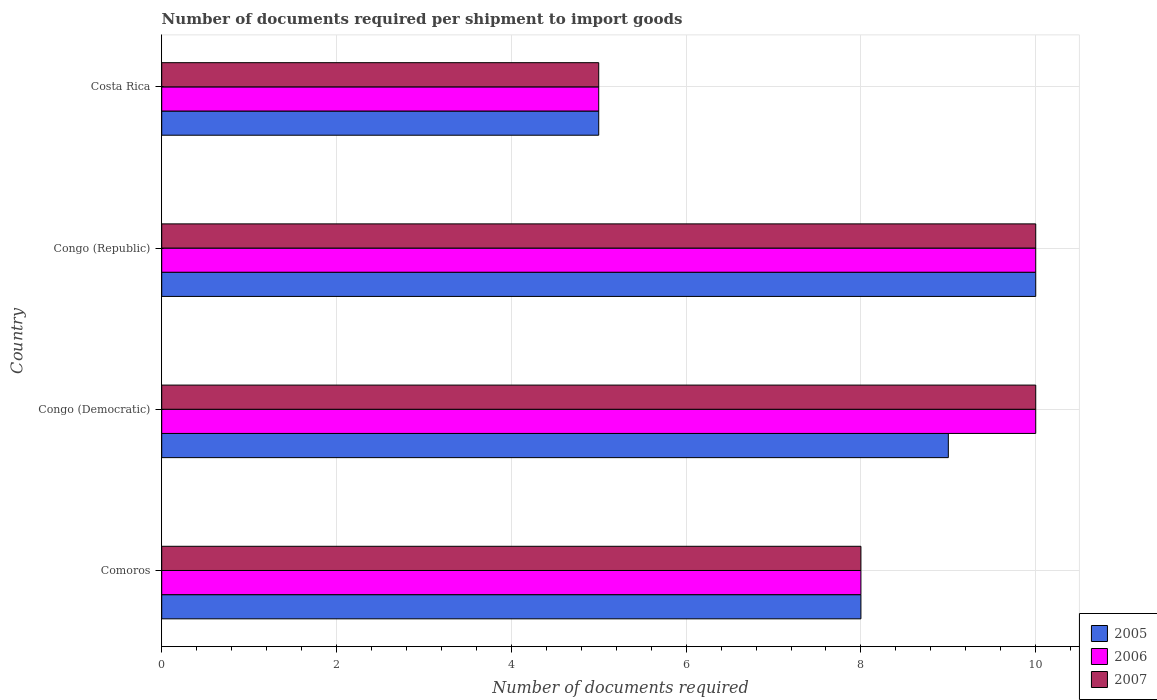Are the number of bars on each tick of the Y-axis equal?
Give a very brief answer. Yes. How many bars are there on the 3rd tick from the bottom?
Provide a short and direct response. 3. What is the label of the 3rd group of bars from the top?
Give a very brief answer. Congo (Democratic). In how many cases, is the number of bars for a given country not equal to the number of legend labels?
Provide a short and direct response. 0. What is the number of documents required per shipment to import goods in 2005 in Comoros?
Offer a very short reply. 8. Across all countries, what is the maximum number of documents required per shipment to import goods in 2005?
Offer a very short reply. 10. Across all countries, what is the minimum number of documents required per shipment to import goods in 2005?
Your answer should be very brief. 5. In which country was the number of documents required per shipment to import goods in 2005 maximum?
Offer a terse response. Congo (Republic). What is the difference between the number of documents required per shipment to import goods in 2005 in Congo (Republic) and the number of documents required per shipment to import goods in 2007 in Congo (Democratic)?
Provide a succinct answer. 0. What is the average number of documents required per shipment to import goods in 2005 per country?
Ensure brevity in your answer.  8. In how many countries, is the number of documents required per shipment to import goods in 2005 greater than 6.4 ?
Give a very brief answer. 3. Is the difference between the number of documents required per shipment to import goods in 2005 in Congo (Democratic) and Costa Rica greater than the difference between the number of documents required per shipment to import goods in 2007 in Congo (Democratic) and Costa Rica?
Provide a short and direct response. No. In how many countries, is the number of documents required per shipment to import goods in 2006 greater than the average number of documents required per shipment to import goods in 2006 taken over all countries?
Your answer should be compact. 2. Is the sum of the number of documents required per shipment to import goods in 2007 in Congo (Democratic) and Costa Rica greater than the maximum number of documents required per shipment to import goods in 2006 across all countries?
Your answer should be compact. Yes. What does the 1st bar from the top in Congo (Republic) represents?
Provide a short and direct response. 2007. Is it the case that in every country, the sum of the number of documents required per shipment to import goods in 2007 and number of documents required per shipment to import goods in 2005 is greater than the number of documents required per shipment to import goods in 2006?
Give a very brief answer. Yes. Are all the bars in the graph horizontal?
Offer a very short reply. Yes. How many countries are there in the graph?
Keep it short and to the point. 4. Are the values on the major ticks of X-axis written in scientific E-notation?
Keep it short and to the point. No. Does the graph contain any zero values?
Your response must be concise. No. Does the graph contain grids?
Ensure brevity in your answer.  Yes. How are the legend labels stacked?
Offer a very short reply. Vertical. What is the title of the graph?
Your answer should be very brief. Number of documents required per shipment to import goods. What is the label or title of the X-axis?
Offer a very short reply. Number of documents required. What is the label or title of the Y-axis?
Make the answer very short. Country. What is the Number of documents required of 2006 in Comoros?
Your response must be concise. 8. What is the Number of documents required in 2005 in Congo (Democratic)?
Ensure brevity in your answer.  9. What is the Number of documents required in 2006 in Congo (Democratic)?
Provide a short and direct response. 10. What is the Number of documents required in 2006 in Congo (Republic)?
Your answer should be very brief. 10. What is the Number of documents required in 2007 in Congo (Republic)?
Offer a very short reply. 10. What is the Number of documents required of 2005 in Costa Rica?
Offer a very short reply. 5. What is the Number of documents required in 2006 in Costa Rica?
Your response must be concise. 5. What is the Number of documents required in 2007 in Costa Rica?
Provide a short and direct response. 5. Across all countries, what is the maximum Number of documents required of 2005?
Your answer should be very brief. 10. Across all countries, what is the minimum Number of documents required of 2007?
Make the answer very short. 5. What is the difference between the Number of documents required of 2007 in Comoros and that in Congo (Democratic)?
Provide a short and direct response. -2. What is the difference between the Number of documents required of 2007 in Comoros and that in Congo (Republic)?
Provide a short and direct response. -2. What is the difference between the Number of documents required in 2007 in Comoros and that in Costa Rica?
Your response must be concise. 3. What is the difference between the Number of documents required of 2005 in Congo (Democratic) and that in Congo (Republic)?
Offer a very short reply. -1. What is the difference between the Number of documents required in 2006 in Congo (Democratic) and that in Congo (Republic)?
Give a very brief answer. 0. What is the difference between the Number of documents required in 2005 in Congo (Republic) and that in Costa Rica?
Give a very brief answer. 5. What is the difference between the Number of documents required of 2006 in Congo (Republic) and that in Costa Rica?
Your response must be concise. 5. What is the difference between the Number of documents required in 2005 in Comoros and the Number of documents required in 2007 in Congo (Democratic)?
Your answer should be compact. -2. What is the difference between the Number of documents required in 2005 in Comoros and the Number of documents required in 2007 in Congo (Republic)?
Keep it short and to the point. -2. What is the difference between the Number of documents required in 2005 in Comoros and the Number of documents required in 2006 in Costa Rica?
Offer a terse response. 3. What is the difference between the Number of documents required in 2006 in Congo (Democratic) and the Number of documents required in 2007 in Costa Rica?
Your response must be concise. 5. What is the difference between the Number of documents required in 2005 in Congo (Republic) and the Number of documents required in 2006 in Costa Rica?
Your answer should be very brief. 5. What is the difference between the Number of documents required in 2005 in Congo (Republic) and the Number of documents required in 2007 in Costa Rica?
Make the answer very short. 5. What is the difference between the Number of documents required in 2006 in Congo (Republic) and the Number of documents required in 2007 in Costa Rica?
Make the answer very short. 5. What is the average Number of documents required of 2006 per country?
Provide a succinct answer. 8.25. What is the average Number of documents required in 2007 per country?
Offer a terse response. 8.25. What is the difference between the Number of documents required in 2005 and Number of documents required in 2006 in Comoros?
Your answer should be very brief. 0. What is the difference between the Number of documents required of 2006 and Number of documents required of 2007 in Comoros?
Ensure brevity in your answer.  0. What is the difference between the Number of documents required in 2005 and Number of documents required in 2006 in Congo (Democratic)?
Offer a terse response. -1. What is the difference between the Number of documents required in 2006 and Number of documents required in 2007 in Congo (Democratic)?
Provide a succinct answer. 0. What is the difference between the Number of documents required in 2005 and Number of documents required in 2006 in Congo (Republic)?
Your answer should be very brief. 0. What is the difference between the Number of documents required in 2005 and Number of documents required in 2007 in Congo (Republic)?
Provide a succinct answer. 0. What is the difference between the Number of documents required of 2006 and Number of documents required of 2007 in Congo (Republic)?
Your response must be concise. 0. What is the difference between the Number of documents required of 2005 and Number of documents required of 2006 in Costa Rica?
Your answer should be compact. 0. What is the difference between the Number of documents required in 2005 and Number of documents required in 2007 in Costa Rica?
Ensure brevity in your answer.  0. What is the difference between the Number of documents required in 2006 and Number of documents required in 2007 in Costa Rica?
Your answer should be compact. 0. What is the ratio of the Number of documents required of 2006 in Comoros to that in Congo (Republic)?
Your answer should be compact. 0.8. What is the ratio of the Number of documents required of 2007 in Comoros to that in Costa Rica?
Give a very brief answer. 1.6. What is the ratio of the Number of documents required of 2005 in Congo (Democratic) to that in Congo (Republic)?
Keep it short and to the point. 0.9. What is the ratio of the Number of documents required in 2006 in Congo (Democratic) to that in Congo (Republic)?
Your response must be concise. 1. What is the ratio of the Number of documents required of 2007 in Congo (Democratic) to that in Congo (Republic)?
Keep it short and to the point. 1. What is the ratio of the Number of documents required in 2007 in Congo (Democratic) to that in Costa Rica?
Provide a succinct answer. 2. What is the ratio of the Number of documents required in 2005 in Congo (Republic) to that in Costa Rica?
Your answer should be very brief. 2. What is the difference between the highest and the second highest Number of documents required of 2005?
Make the answer very short. 1. What is the difference between the highest and the second highest Number of documents required of 2006?
Your answer should be very brief. 0. What is the difference between the highest and the second highest Number of documents required of 2007?
Your answer should be compact. 0. What is the difference between the highest and the lowest Number of documents required of 2005?
Ensure brevity in your answer.  5. What is the difference between the highest and the lowest Number of documents required of 2007?
Provide a short and direct response. 5. 